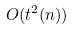Convert formula to latex. <formula><loc_0><loc_0><loc_500><loc_500>O ( t ^ { 2 } ( n ) )</formula> 